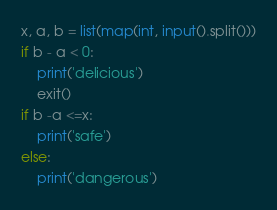<code> <loc_0><loc_0><loc_500><loc_500><_Python_>x, a, b = list(map(int, input().split()))
if b - a < 0:
    print('delicious')
    exit()
if b -a <=x:
    print('safe')
else:
    print('dangerous')</code> 